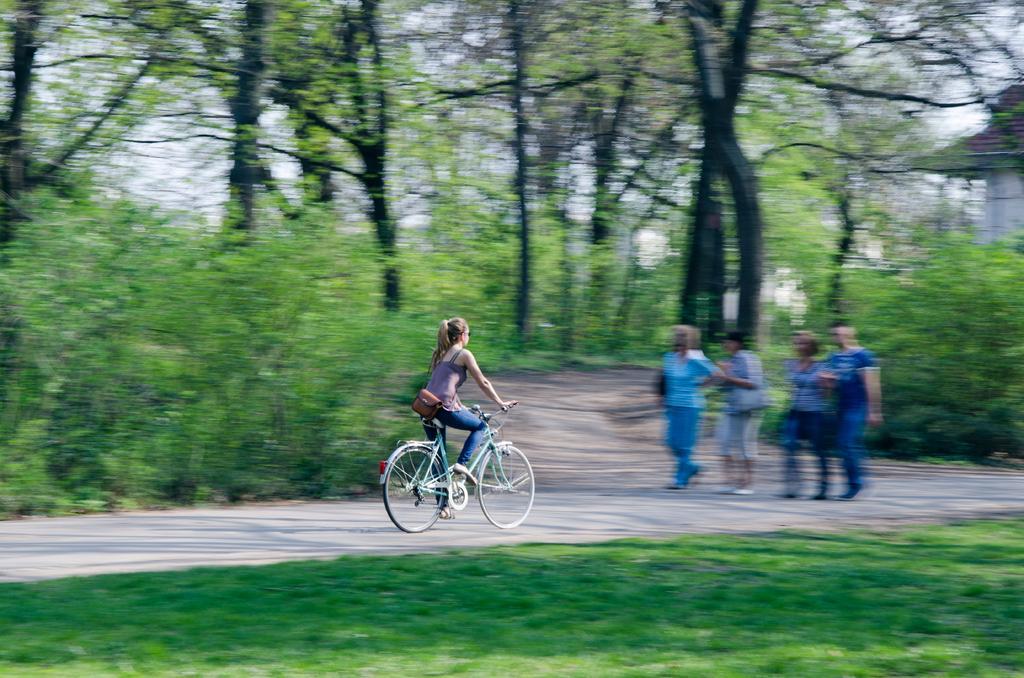Please provide a concise description of this image. In this picture there are people, among them there is a woman riding bicycle on the road and we can see grass and plants. In the background of the image it is blurry and we can see trees, sky and wall. 